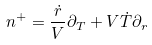<formula> <loc_0><loc_0><loc_500><loc_500>n ^ { + } = \frac { \dot { r } } { V } \partial _ { T } + V \dot { T } \partial _ { r }</formula> 